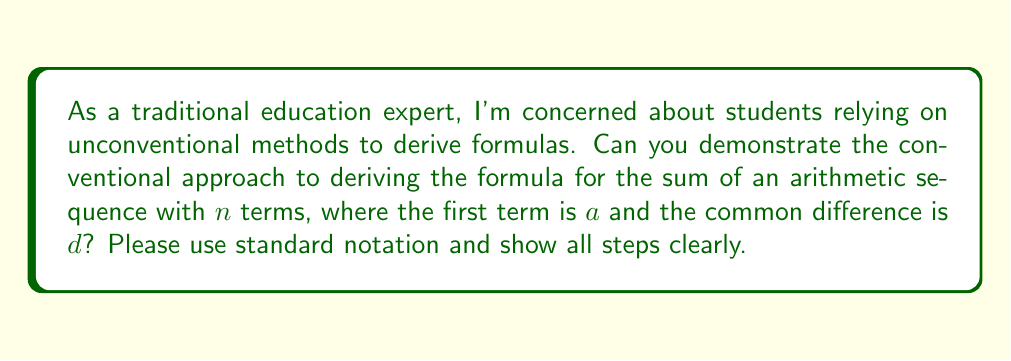Help me with this question. Let's derive the formula for the sum of an arithmetic sequence using conventional notation and methods:

1) Let $S_n$ represent the sum of $n$ terms in the arithmetic sequence.

2) Write out the sum in two ways:
   $$S_n = a + (a+d) + (a+2d) + ... + (a+(n-2)d) + (a+(n-1)d)$$
   $$S_n = (a+(n-1)d) + (a+(n-2)d) + ... + (a+d) + a$$

3) Add these two equations:
   $$2S_n = [a + (a+(n-1)d)] + [a + (a+(n-1)d)] + ... + [a + (a+(n-1)d)]$$

4) Observe that there are $n$ pairs of terms in brackets, each summing to $2a+(n-1)d$.

5) Therefore:
   $$2S_n = n[2a+(n-1)d]$$

6) Divide both sides by 2:
   $$S_n = \frac{n}{2}[2a+(n-1)d]$$

7) This can be rewritten as:
   $$S_n = \frac{n}{2}[a + (a+(n-1)d)]$$

8) Recognize that $a+(n-1)d$ is the last term of the sequence, often denoted as $l$.

9) Thus, the final formula is:
   $$S_n = \frac{n}{2}(a + l)$$

This derivation follows the conventional approach taught in traditional precalculus courses.
Answer: $$S_n = \frac{n}{2}(a + l)$$ where $S_n$ is the sum of $n$ terms, $a$ is the first term, and $l$ is the last term of the arithmetic sequence. 